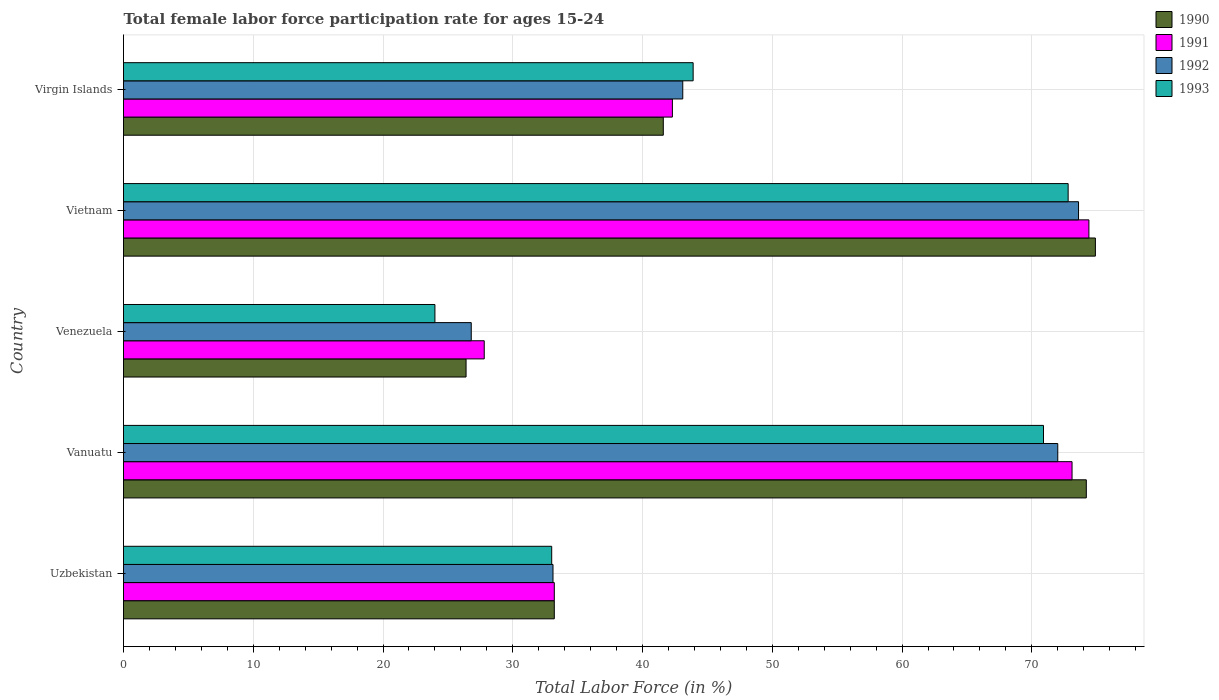How many different coloured bars are there?
Your response must be concise. 4. How many groups of bars are there?
Your response must be concise. 5. Are the number of bars per tick equal to the number of legend labels?
Your answer should be compact. Yes. How many bars are there on the 5th tick from the bottom?
Offer a terse response. 4. What is the label of the 3rd group of bars from the top?
Provide a short and direct response. Venezuela. In how many cases, is the number of bars for a given country not equal to the number of legend labels?
Your response must be concise. 0. What is the female labor force participation rate in 1993 in Vanuatu?
Ensure brevity in your answer.  70.9. Across all countries, what is the maximum female labor force participation rate in 1992?
Offer a very short reply. 73.6. Across all countries, what is the minimum female labor force participation rate in 1992?
Your answer should be very brief. 26.8. In which country was the female labor force participation rate in 1991 maximum?
Offer a terse response. Vietnam. In which country was the female labor force participation rate in 1993 minimum?
Your response must be concise. Venezuela. What is the total female labor force participation rate in 1991 in the graph?
Ensure brevity in your answer.  250.8. What is the difference between the female labor force participation rate in 1991 in Vietnam and that in Virgin Islands?
Make the answer very short. 32.1. What is the difference between the female labor force participation rate in 1990 in Virgin Islands and the female labor force participation rate in 1992 in Vietnam?
Provide a short and direct response. -32. What is the average female labor force participation rate in 1990 per country?
Offer a terse response. 50.06. What is the difference between the female labor force participation rate in 1992 and female labor force participation rate in 1991 in Vietnam?
Offer a very short reply. -0.8. What is the ratio of the female labor force participation rate in 1991 in Vietnam to that in Virgin Islands?
Give a very brief answer. 1.76. What is the difference between the highest and the second highest female labor force participation rate in 1991?
Offer a very short reply. 1.3. What is the difference between the highest and the lowest female labor force participation rate in 1991?
Offer a very short reply. 46.6. In how many countries, is the female labor force participation rate in 1993 greater than the average female labor force participation rate in 1993 taken over all countries?
Offer a terse response. 2. Is the sum of the female labor force participation rate in 1993 in Vanuatu and Vietnam greater than the maximum female labor force participation rate in 1991 across all countries?
Your response must be concise. Yes. Is it the case that in every country, the sum of the female labor force participation rate in 1990 and female labor force participation rate in 1993 is greater than the female labor force participation rate in 1991?
Offer a terse response. Yes. Are all the bars in the graph horizontal?
Provide a succinct answer. Yes. How many countries are there in the graph?
Offer a very short reply. 5. Does the graph contain any zero values?
Your answer should be compact. No. Where does the legend appear in the graph?
Ensure brevity in your answer.  Top right. How many legend labels are there?
Your response must be concise. 4. How are the legend labels stacked?
Your response must be concise. Vertical. What is the title of the graph?
Offer a terse response. Total female labor force participation rate for ages 15-24. What is the label or title of the X-axis?
Make the answer very short. Total Labor Force (in %). What is the label or title of the Y-axis?
Your answer should be very brief. Country. What is the Total Labor Force (in %) of 1990 in Uzbekistan?
Provide a succinct answer. 33.2. What is the Total Labor Force (in %) of 1991 in Uzbekistan?
Make the answer very short. 33.2. What is the Total Labor Force (in %) of 1992 in Uzbekistan?
Your response must be concise. 33.1. What is the Total Labor Force (in %) in 1990 in Vanuatu?
Your answer should be compact. 74.2. What is the Total Labor Force (in %) of 1991 in Vanuatu?
Provide a succinct answer. 73.1. What is the Total Labor Force (in %) of 1992 in Vanuatu?
Offer a very short reply. 72. What is the Total Labor Force (in %) of 1993 in Vanuatu?
Your response must be concise. 70.9. What is the Total Labor Force (in %) of 1990 in Venezuela?
Keep it short and to the point. 26.4. What is the Total Labor Force (in %) in 1991 in Venezuela?
Ensure brevity in your answer.  27.8. What is the Total Labor Force (in %) of 1992 in Venezuela?
Offer a very short reply. 26.8. What is the Total Labor Force (in %) of 1993 in Venezuela?
Your answer should be compact. 24. What is the Total Labor Force (in %) in 1990 in Vietnam?
Make the answer very short. 74.9. What is the Total Labor Force (in %) of 1991 in Vietnam?
Offer a very short reply. 74.4. What is the Total Labor Force (in %) of 1992 in Vietnam?
Ensure brevity in your answer.  73.6. What is the Total Labor Force (in %) of 1993 in Vietnam?
Provide a succinct answer. 72.8. What is the Total Labor Force (in %) in 1990 in Virgin Islands?
Your answer should be very brief. 41.6. What is the Total Labor Force (in %) of 1991 in Virgin Islands?
Ensure brevity in your answer.  42.3. What is the Total Labor Force (in %) of 1992 in Virgin Islands?
Keep it short and to the point. 43.1. What is the Total Labor Force (in %) of 1993 in Virgin Islands?
Keep it short and to the point. 43.9. Across all countries, what is the maximum Total Labor Force (in %) of 1990?
Offer a terse response. 74.9. Across all countries, what is the maximum Total Labor Force (in %) of 1991?
Provide a succinct answer. 74.4. Across all countries, what is the maximum Total Labor Force (in %) of 1992?
Offer a very short reply. 73.6. Across all countries, what is the maximum Total Labor Force (in %) of 1993?
Provide a succinct answer. 72.8. Across all countries, what is the minimum Total Labor Force (in %) in 1990?
Provide a succinct answer. 26.4. Across all countries, what is the minimum Total Labor Force (in %) in 1991?
Make the answer very short. 27.8. Across all countries, what is the minimum Total Labor Force (in %) in 1992?
Your answer should be very brief. 26.8. Across all countries, what is the minimum Total Labor Force (in %) in 1993?
Provide a short and direct response. 24. What is the total Total Labor Force (in %) in 1990 in the graph?
Your answer should be very brief. 250.3. What is the total Total Labor Force (in %) of 1991 in the graph?
Keep it short and to the point. 250.8. What is the total Total Labor Force (in %) in 1992 in the graph?
Provide a short and direct response. 248.6. What is the total Total Labor Force (in %) in 1993 in the graph?
Provide a succinct answer. 244.6. What is the difference between the Total Labor Force (in %) in 1990 in Uzbekistan and that in Vanuatu?
Ensure brevity in your answer.  -41. What is the difference between the Total Labor Force (in %) of 1991 in Uzbekistan and that in Vanuatu?
Your answer should be compact. -39.9. What is the difference between the Total Labor Force (in %) of 1992 in Uzbekistan and that in Vanuatu?
Make the answer very short. -38.9. What is the difference between the Total Labor Force (in %) of 1993 in Uzbekistan and that in Vanuatu?
Your answer should be very brief. -37.9. What is the difference between the Total Labor Force (in %) of 1990 in Uzbekistan and that in Venezuela?
Make the answer very short. 6.8. What is the difference between the Total Labor Force (in %) in 1992 in Uzbekistan and that in Venezuela?
Your response must be concise. 6.3. What is the difference between the Total Labor Force (in %) of 1993 in Uzbekistan and that in Venezuela?
Give a very brief answer. 9. What is the difference between the Total Labor Force (in %) of 1990 in Uzbekistan and that in Vietnam?
Give a very brief answer. -41.7. What is the difference between the Total Labor Force (in %) of 1991 in Uzbekistan and that in Vietnam?
Your answer should be very brief. -41.2. What is the difference between the Total Labor Force (in %) of 1992 in Uzbekistan and that in Vietnam?
Offer a very short reply. -40.5. What is the difference between the Total Labor Force (in %) in 1993 in Uzbekistan and that in Vietnam?
Offer a very short reply. -39.8. What is the difference between the Total Labor Force (in %) in 1990 in Uzbekistan and that in Virgin Islands?
Ensure brevity in your answer.  -8.4. What is the difference between the Total Labor Force (in %) of 1992 in Uzbekistan and that in Virgin Islands?
Offer a very short reply. -10. What is the difference between the Total Labor Force (in %) in 1990 in Vanuatu and that in Venezuela?
Your response must be concise. 47.8. What is the difference between the Total Labor Force (in %) of 1991 in Vanuatu and that in Venezuela?
Keep it short and to the point. 45.3. What is the difference between the Total Labor Force (in %) in 1992 in Vanuatu and that in Venezuela?
Your response must be concise. 45.2. What is the difference between the Total Labor Force (in %) in 1993 in Vanuatu and that in Venezuela?
Your answer should be very brief. 46.9. What is the difference between the Total Labor Force (in %) in 1990 in Vanuatu and that in Vietnam?
Offer a very short reply. -0.7. What is the difference between the Total Labor Force (in %) in 1991 in Vanuatu and that in Vietnam?
Make the answer very short. -1.3. What is the difference between the Total Labor Force (in %) of 1992 in Vanuatu and that in Vietnam?
Offer a terse response. -1.6. What is the difference between the Total Labor Force (in %) of 1990 in Vanuatu and that in Virgin Islands?
Offer a very short reply. 32.6. What is the difference between the Total Labor Force (in %) in 1991 in Vanuatu and that in Virgin Islands?
Give a very brief answer. 30.8. What is the difference between the Total Labor Force (in %) in 1992 in Vanuatu and that in Virgin Islands?
Your answer should be very brief. 28.9. What is the difference between the Total Labor Force (in %) in 1990 in Venezuela and that in Vietnam?
Your answer should be compact. -48.5. What is the difference between the Total Labor Force (in %) of 1991 in Venezuela and that in Vietnam?
Your answer should be very brief. -46.6. What is the difference between the Total Labor Force (in %) in 1992 in Venezuela and that in Vietnam?
Your response must be concise. -46.8. What is the difference between the Total Labor Force (in %) of 1993 in Venezuela and that in Vietnam?
Give a very brief answer. -48.8. What is the difference between the Total Labor Force (in %) of 1990 in Venezuela and that in Virgin Islands?
Offer a terse response. -15.2. What is the difference between the Total Labor Force (in %) in 1991 in Venezuela and that in Virgin Islands?
Your answer should be compact. -14.5. What is the difference between the Total Labor Force (in %) in 1992 in Venezuela and that in Virgin Islands?
Keep it short and to the point. -16.3. What is the difference between the Total Labor Force (in %) of 1993 in Venezuela and that in Virgin Islands?
Keep it short and to the point. -19.9. What is the difference between the Total Labor Force (in %) of 1990 in Vietnam and that in Virgin Islands?
Provide a succinct answer. 33.3. What is the difference between the Total Labor Force (in %) of 1991 in Vietnam and that in Virgin Islands?
Provide a succinct answer. 32.1. What is the difference between the Total Labor Force (in %) of 1992 in Vietnam and that in Virgin Islands?
Your answer should be compact. 30.5. What is the difference between the Total Labor Force (in %) in 1993 in Vietnam and that in Virgin Islands?
Ensure brevity in your answer.  28.9. What is the difference between the Total Labor Force (in %) of 1990 in Uzbekistan and the Total Labor Force (in %) of 1991 in Vanuatu?
Offer a terse response. -39.9. What is the difference between the Total Labor Force (in %) in 1990 in Uzbekistan and the Total Labor Force (in %) in 1992 in Vanuatu?
Provide a short and direct response. -38.8. What is the difference between the Total Labor Force (in %) in 1990 in Uzbekistan and the Total Labor Force (in %) in 1993 in Vanuatu?
Provide a succinct answer. -37.7. What is the difference between the Total Labor Force (in %) of 1991 in Uzbekistan and the Total Labor Force (in %) of 1992 in Vanuatu?
Your response must be concise. -38.8. What is the difference between the Total Labor Force (in %) in 1991 in Uzbekistan and the Total Labor Force (in %) in 1993 in Vanuatu?
Offer a very short reply. -37.7. What is the difference between the Total Labor Force (in %) of 1992 in Uzbekistan and the Total Labor Force (in %) of 1993 in Vanuatu?
Make the answer very short. -37.8. What is the difference between the Total Labor Force (in %) of 1990 in Uzbekistan and the Total Labor Force (in %) of 1993 in Venezuela?
Offer a very short reply. 9.2. What is the difference between the Total Labor Force (in %) in 1992 in Uzbekistan and the Total Labor Force (in %) in 1993 in Venezuela?
Provide a short and direct response. 9.1. What is the difference between the Total Labor Force (in %) of 1990 in Uzbekistan and the Total Labor Force (in %) of 1991 in Vietnam?
Your answer should be compact. -41.2. What is the difference between the Total Labor Force (in %) of 1990 in Uzbekistan and the Total Labor Force (in %) of 1992 in Vietnam?
Provide a short and direct response. -40.4. What is the difference between the Total Labor Force (in %) of 1990 in Uzbekistan and the Total Labor Force (in %) of 1993 in Vietnam?
Your answer should be compact. -39.6. What is the difference between the Total Labor Force (in %) of 1991 in Uzbekistan and the Total Labor Force (in %) of 1992 in Vietnam?
Your answer should be very brief. -40.4. What is the difference between the Total Labor Force (in %) of 1991 in Uzbekistan and the Total Labor Force (in %) of 1993 in Vietnam?
Make the answer very short. -39.6. What is the difference between the Total Labor Force (in %) of 1992 in Uzbekistan and the Total Labor Force (in %) of 1993 in Vietnam?
Make the answer very short. -39.7. What is the difference between the Total Labor Force (in %) of 1990 in Uzbekistan and the Total Labor Force (in %) of 1991 in Virgin Islands?
Provide a short and direct response. -9.1. What is the difference between the Total Labor Force (in %) in 1990 in Uzbekistan and the Total Labor Force (in %) in 1992 in Virgin Islands?
Keep it short and to the point. -9.9. What is the difference between the Total Labor Force (in %) of 1991 in Uzbekistan and the Total Labor Force (in %) of 1993 in Virgin Islands?
Keep it short and to the point. -10.7. What is the difference between the Total Labor Force (in %) in 1990 in Vanuatu and the Total Labor Force (in %) in 1991 in Venezuela?
Ensure brevity in your answer.  46.4. What is the difference between the Total Labor Force (in %) of 1990 in Vanuatu and the Total Labor Force (in %) of 1992 in Venezuela?
Provide a succinct answer. 47.4. What is the difference between the Total Labor Force (in %) of 1990 in Vanuatu and the Total Labor Force (in %) of 1993 in Venezuela?
Your answer should be compact. 50.2. What is the difference between the Total Labor Force (in %) of 1991 in Vanuatu and the Total Labor Force (in %) of 1992 in Venezuela?
Make the answer very short. 46.3. What is the difference between the Total Labor Force (in %) in 1991 in Vanuatu and the Total Labor Force (in %) in 1993 in Venezuela?
Your answer should be compact. 49.1. What is the difference between the Total Labor Force (in %) in 1990 in Vanuatu and the Total Labor Force (in %) in 1991 in Vietnam?
Offer a terse response. -0.2. What is the difference between the Total Labor Force (in %) of 1990 in Vanuatu and the Total Labor Force (in %) of 1993 in Vietnam?
Your answer should be compact. 1.4. What is the difference between the Total Labor Force (in %) in 1992 in Vanuatu and the Total Labor Force (in %) in 1993 in Vietnam?
Your answer should be very brief. -0.8. What is the difference between the Total Labor Force (in %) of 1990 in Vanuatu and the Total Labor Force (in %) of 1991 in Virgin Islands?
Your response must be concise. 31.9. What is the difference between the Total Labor Force (in %) in 1990 in Vanuatu and the Total Labor Force (in %) in 1992 in Virgin Islands?
Make the answer very short. 31.1. What is the difference between the Total Labor Force (in %) in 1990 in Vanuatu and the Total Labor Force (in %) in 1993 in Virgin Islands?
Make the answer very short. 30.3. What is the difference between the Total Labor Force (in %) in 1991 in Vanuatu and the Total Labor Force (in %) in 1993 in Virgin Islands?
Your answer should be very brief. 29.2. What is the difference between the Total Labor Force (in %) in 1992 in Vanuatu and the Total Labor Force (in %) in 1993 in Virgin Islands?
Provide a short and direct response. 28.1. What is the difference between the Total Labor Force (in %) in 1990 in Venezuela and the Total Labor Force (in %) in 1991 in Vietnam?
Your answer should be very brief. -48. What is the difference between the Total Labor Force (in %) of 1990 in Venezuela and the Total Labor Force (in %) of 1992 in Vietnam?
Make the answer very short. -47.2. What is the difference between the Total Labor Force (in %) of 1990 in Venezuela and the Total Labor Force (in %) of 1993 in Vietnam?
Provide a short and direct response. -46.4. What is the difference between the Total Labor Force (in %) of 1991 in Venezuela and the Total Labor Force (in %) of 1992 in Vietnam?
Your answer should be compact. -45.8. What is the difference between the Total Labor Force (in %) in 1991 in Venezuela and the Total Labor Force (in %) in 1993 in Vietnam?
Give a very brief answer. -45. What is the difference between the Total Labor Force (in %) of 1992 in Venezuela and the Total Labor Force (in %) of 1993 in Vietnam?
Provide a succinct answer. -46. What is the difference between the Total Labor Force (in %) in 1990 in Venezuela and the Total Labor Force (in %) in 1991 in Virgin Islands?
Offer a terse response. -15.9. What is the difference between the Total Labor Force (in %) of 1990 in Venezuela and the Total Labor Force (in %) of 1992 in Virgin Islands?
Ensure brevity in your answer.  -16.7. What is the difference between the Total Labor Force (in %) in 1990 in Venezuela and the Total Labor Force (in %) in 1993 in Virgin Islands?
Ensure brevity in your answer.  -17.5. What is the difference between the Total Labor Force (in %) of 1991 in Venezuela and the Total Labor Force (in %) of 1992 in Virgin Islands?
Give a very brief answer. -15.3. What is the difference between the Total Labor Force (in %) in 1991 in Venezuela and the Total Labor Force (in %) in 1993 in Virgin Islands?
Provide a short and direct response. -16.1. What is the difference between the Total Labor Force (in %) of 1992 in Venezuela and the Total Labor Force (in %) of 1993 in Virgin Islands?
Ensure brevity in your answer.  -17.1. What is the difference between the Total Labor Force (in %) in 1990 in Vietnam and the Total Labor Force (in %) in 1991 in Virgin Islands?
Ensure brevity in your answer.  32.6. What is the difference between the Total Labor Force (in %) of 1990 in Vietnam and the Total Labor Force (in %) of 1992 in Virgin Islands?
Your response must be concise. 31.8. What is the difference between the Total Labor Force (in %) of 1991 in Vietnam and the Total Labor Force (in %) of 1992 in Virgin Islands?
Make the answer very short. 31.3. What is the difference between the Total Labor Force (in %) of 1991 in Vietnam and the Total Labor Force (in %) of 1993 in Virgin Islands?
Your response must be concise. 30.5. What is the difference between the Total Labor Force (in %) of 1992 in Vietnam and the Total Labor Force (in %) of 1993 in Virgin Islands?
Offer a very short reply. 29.7. What is the average Total Labor Force (in %) of 1990 per country?
Provide a short and direct response. 50.06. What is the average Total Labor Force (in %) of 1991 per country?
Provide a succinct answer. 50.16. What is the average Total Labor Force (in %) of 1992 per country?
Give a very brief answer. 49.72. What is the average Total Labor Force (in %) of 1993 per country?
Provide a short and direct response. 48.92. What is the difference between the Total Labor Force (in %) in 1990 and Total Labor Force (in %) in 1992 in Uzbekistan?
Offer a very short reply. 0.1. What is the difference between the Total Labor Force (in %) in 1991 and Total Labor Force (in %) in 1993 in Uzbekistan?
Provide a short and direct response. 0.2. What is the difference between the Total Labor Force (in %) in 1990 and Total Labor Force (in %) in 1991 in Vanuatu?
Offer a terse response. 1.1. What is the difference between the Total Labor Force (in %) of 1990 and Total Labor Force (in %) of 1992 in Vanuatu?
Offer a very short reply. 2.2. What is the difference between the Total Labor Force (in %) in 1992 and Total Labor Force (in %) in 1993 in Vanuatu?
Your response must be concise. 1.1. What is the difference between the Total Labor Force (in %) of 1991 and Total Labor Force (in %) of 1992 in Venezuela?
Offer a very short reply. 1. What is the difference between the Total Labor Force (in %) in 1990 and Total Labor Force (in %) in 1991 in Vietnam?
Give a very brief answer. 0.5. What is the difference between the Total Labor Force (in %) in 1990 and Total Labor Force (in %) in 1992 in Vietnam?
Ensure brevity in your answer.  1.3. What is the difference between the Total Labor Force (in %) in 1991 and Total Labor Force (in %) in 1992 in Vietnam?
Ensure brevity in your answer.  0.8. What is the difference between the Total Labor Force (in %) in 1990 and Total Labor Force (in %) in 1991 in Virgin Islands?
Offer a very short reply. -0.7. What is the difference between the Total Labor Force (in %) of 1990 and Total Labor Force (in %) of 1992 in Virgin Islands?
Keep it short and to the point. -1.5. What is the ratio of the Total Labor Force (in %) in 1990 in Uzbekistan to that in Vanuatu?
Your answer should be very brief. 0.45. What is the ratio of the Total Labor Force (in %) in 1991 in Uzbekistan to that in Vanuatu?
Keep it short and to the point. 0.45. What is the ratio of the Total Labor Force (in %) of 1992 in Uzbekistan to that in Vanuatu?
Your answer should be compact. 0.46. What is the ratio of the Total Labor Force (in %) in 1993 in Uzbekistan to that in Vanuatu?
Ensure brevity in your answer.  0.47. What is the ratio of the Total Labor Force (in %) of 1990 in Uzbekistan to that in Venezuela?
Provide a succinct answer. 1.26. What is the ratio of the Total Labor Force (in %) in 1991 in Uzbekistan to that in Venezuela?
Offer a terse response. 1.19. What is the ratio of the Total Labor Force (in %) in 1992 in Uzbekistan to that in Venezuela?
Give a very brief answer. 1.24. What is the ratio of the Total Labor Force (in %) in 1993 in Uzbekistan to that in Venezuela?
Provide a succinct answer. 1.38. What is the ratio of the Total Labor Force (in %) of 1990 in Uzbekistan to that in Vietnam?
Ensure brevity in your answer.  0.44. What is the ratio of the Total Labor Force (in %) of 1991 in Uzbekistan to that in Vietnam?
Give a very brief answer. 0.45. What is the ratio of the Total Labor Force (in %) in 1992 in Uzbekistan to that in Vietnam?
Ensure brevity in your answer.  0.45. What is the ratio of the Total Labor Force (in %) of 1993 in Uzbekistan to that in Vietnam?
Make the answer very short. 0.45. What is the ratio of the Total Labor Force (in %) in 1990 in Uzbekistan to that in Virgin Islands?
Offer a very short reply. 0.8. What is the ratio of the Total Labor Force (in %) in 1991 in Uzbekistan to that in Virgin Islands?
Keep it short and to the point. 0.78. What is the ratio of the Total Labor Force (in %) of 1992 in Uzbekistan to that in Virgin Islands?
Provide a succinct answer. 0.77. What is the ratio of the Total Labor Force (in %) of 1993 in Uzbekistan to that in Virgin Islands?
Ensure brevity in your answer.  0.75. What is the ratio of the Total Labor Force (in %) in 1990 in Vanuatu to that in Venezuela?
Offer a very short reply. 2.81. What is the ratio of the Total Labor Force (in %) in 1991 in Vanuatu to that in Venezuela?
Ensure brevity in your answer.  2.63. What is the ratio of the Total Labor Force (in %) in 1992 in Vanuatu to that in Venezuela?
Offer a very short reply. 2.69. What is the ratio of the Total Labor Force (in %) in 1993 in Vanuatu to that in Venezuela?
Your answer should be very brief. 2.95. What is the ratio of the Total Labor Force (in %) in 1991 in Vanuatu to that in Vietnam?
Offer a terse response. 0.98. What is the ratio of the Total Labor Force (in %) of 1992 in Vanuatu to that in Vietnam?
Your answer should be very brief. 0.98. What is the ratio of the Total Labor Force (in %) in 1993 in Vanuatu to that in Vietnam?
Offer a very short reply. 0.97. What is the ratio of the Total Labor Force (in %) of 1990 in Vanuatu to that in Virgin Islands?
Your response must be concise. 1.78. What is the ratio of the Total Labor Force (in %) in 1991 in Vanuatu to that in Virgin Islands?
Provide a succinct answer. 1.73. What is the ratio of the Total Labor Force (in %) in 1992 in Vanuatu to that in Virgin Islands?
Keep it short and to the point. 1.67. What is the ratio of the Total Labor Force (in %) of 1993 in Vanuatu to that in Virgin Islands?
Offer a terse response. 1.61. What is the ratio of the Total Labor Force (in %) of 1990 in Venezuela to that in Vietnam?
Your response must be concise. 0.35. What is the ratio of the Total Labor Force (in %) of 1991 in Venezuela to that in Vietnam?
Provide a short and direct response. 0.37. What is the ratio of the Total Labor Force (in %) in 1992 in Venezuela to that in Vietnam?
Ensure brevity in your answer.  0.36. What is the ratio of the Total Labor Force (in %) of 1993 in Venezuela to that in Vietnam?
Offer a very short reply. 0.33. What is the ratio of the Total Labor Force (in %) in 1990 in Venezuela to that in Virgin Islands?
Offer a terse response. 0.63. What is the ratio of the Total Labor Force (in %) of 1991 in Venezuela to that in Virgin Islands?
Your answer should be very brief. 0.66. What is the ratio of the Total Labor Force (in %) in 1992 in Venezuela to that in Virgin Islands?
Provide a succinct answer. 0.62. What is the ratio of the Total Labor Force (in %) in 1993 in Venezuela to that in Virgin Islands?
Keep it short and to the point. 0.55. What is the ratio of the Total Labor Force (in %) of 1990 in Vietnam to that in Virgin Islands?
Offer a very short reply. 1.8. What is the ratio of the Total Labor Force (in %) of 1991 in Vietnam to that in Virgin Islands?
Make the answer very short. 1.76. What is the ratio of the Total Labor Force (in %) of 1992 in Vietnam to that in Virgin Islands?
Ensure brevity in your answer.  1.71. What is the ratio of the Total Labor Force (in %) of 1993 in Vietnam to that in Virgin Islands?
Keep it short and to the point. 1.66. What is the difference between the highest and the second highest Total Labor Force (in %) of 1990?
Ensure brevity in your answer.  0.7. What is the difference between the highest and the lowest Total Labor Force (in %) of 1990?
Your answer should be very brief. 48.5. What is the difference between the highest and the lowest Total Labor Force (in %) of 1991?
Keep it short and to the point. 46.6. What is the difference between the highest and the lowest Total Labor Force (in %) in 1992?
Give a very brief answer. 46.8. What is the difference between the highest and the lowest Total Labor Force (in %) in 1993?
Your answer should be compact. 48.8. 